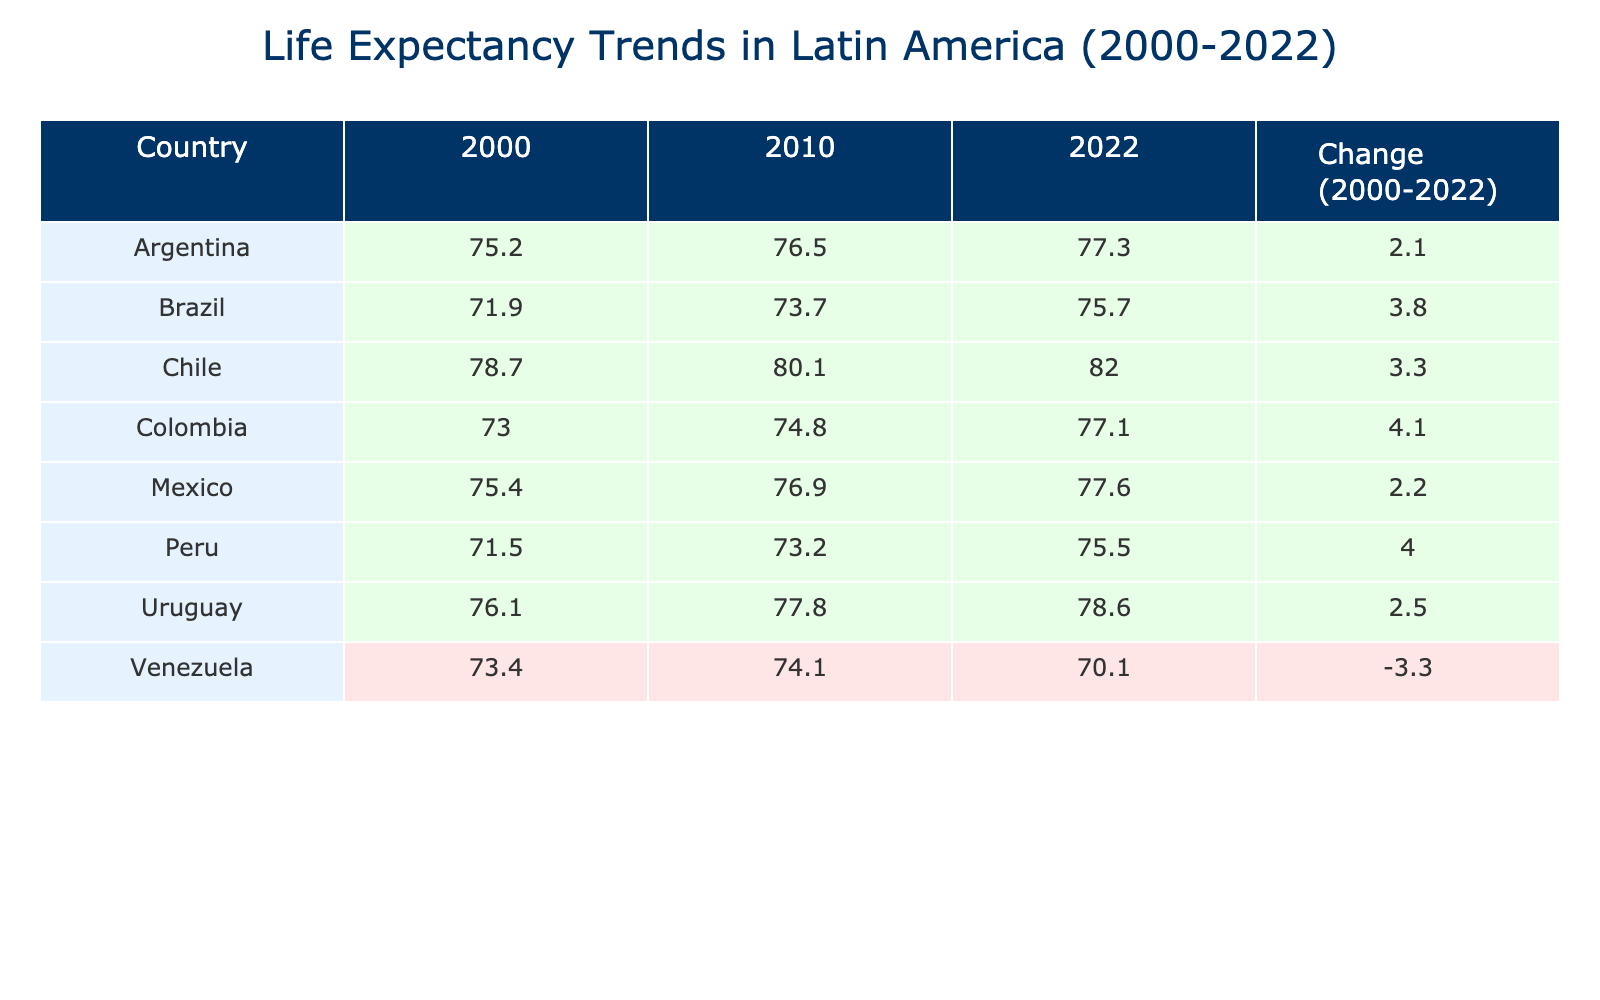What was the life expectancy in Chile in 2022? Looking at the table, under the column for the year 2022, the value for Chile is directly listed as 82.0 years.
Answer: 82.0 Which country had the highest life expectancy in 2010? In the 2010 column, life expectancies for all countries are listed. By comparing the values, Chile has the highest value listed at 80.1 years.
Answer: Chile What is the change in life expectancy for Argentina from 2000 to 2022? The table shows life expectancy for Argentina as 75.2 in 2000 and 77.3 in 2022. The change can be calculated by subtracting 75.2 from 77.3, which results in 2.1 years.
Answer: 2.1 Is it true that Venezuela's life expectancy decreased from 2010 to 2022? In the table, Venezuela's life expectancy is 74.1 in 2010 and 70.1 in 2022. The value decreased, confirming that the statement is true.
Answer: Yes What is the average life expectancy in Brazil for the years 2000 and 2022? For Brazil, the life expectancy in 2000 is 71.9 and in 2022 is 75.7. Adding these together gives 71.9 + 75.7 = 147.6. Dividing by 2 to find the average gives 147.6 / 2 = 73.8.
Answer: 73.8 Which country experienced the greatest increase in life expectancy from 2000 to 2022? By reviewing the 'Change (2000-2022)' column, we see values for each country. The highest value is for Chile with an increase of 3.3 years, indicating it experienced the greatest increase.
Answer: Chile How many countries have a life expectancy above 77 years in 2022? Examining the 2022 column, the countries with values above 77 years are Chile (82.0), Argentina (77.3), Mexico (77.6), and Uruguay (78.6). Counting these gives a total of 4 countries.
Answer: 4 Is Colombia's life expectancy higher than Argentina's in 2022? The life expectancy for Colombia in 2022 is 77.1, while Argentina's is 77.3. Since 77.1 is less than 77.3, the statement is false.
Answer: No What is the combined life expectancy of Mexico and Peru in 2010? In 2010, life expectancy for Mexico is 76.9 and for Peru is 73.2. Adding these values gives 76.9 + 73.2 = 150.1 years, which indicates the combined life expectancy.
Answer: 150.1 